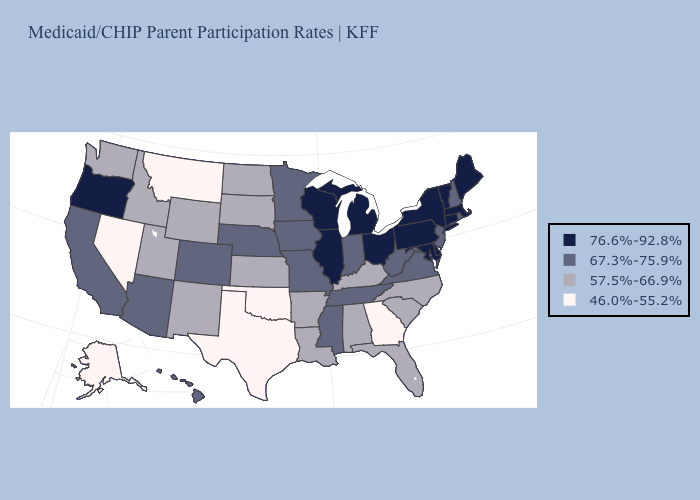What is the lowest value in the MidWest?
Keep it brief. 57.5%-66.9%. Does Montana have the lowest value in the West?
Answer briefly. Yes. Name the states that have a value in the range 67.3%-75.9%?
Write a very short answer. Arizona, California, Colorado, Hawaii, Indiana, Iowa, Minnesota, Mississippi, Missouri, Nebraska, New Hampshire, New Jersey, Rhode Island, Tennessee, Virginia, West Virginia. Is the legend a continuous bar?
Keep it brief. No. What is the value of Maine?
Quick response, please. 76.6%-92.8%. Among the states that border Florida , does Georgia have the highest value?
Concise answer only. No. What is the value of Hawaii?
Short answer required. 67.3%-75.9%. What is the value of Arizona?
Give a very brief answer. 67.3%-75.9%. What is the value of South Carolina?
Give a very brief answer. 57.5%-66.9%. Does New Hampshire have the lowest value in the USA?
Short answer required. No. Which states hav the highest value in the South?
Quick response, please. Delaware, Maryland. Does Nevada have the lowest value in the West?
Give a very brief answer. Yes. How many symbols are there in the legend?
Answer briefly. 4. How many symbols are there in the legend?
Answer briefly. 4. 